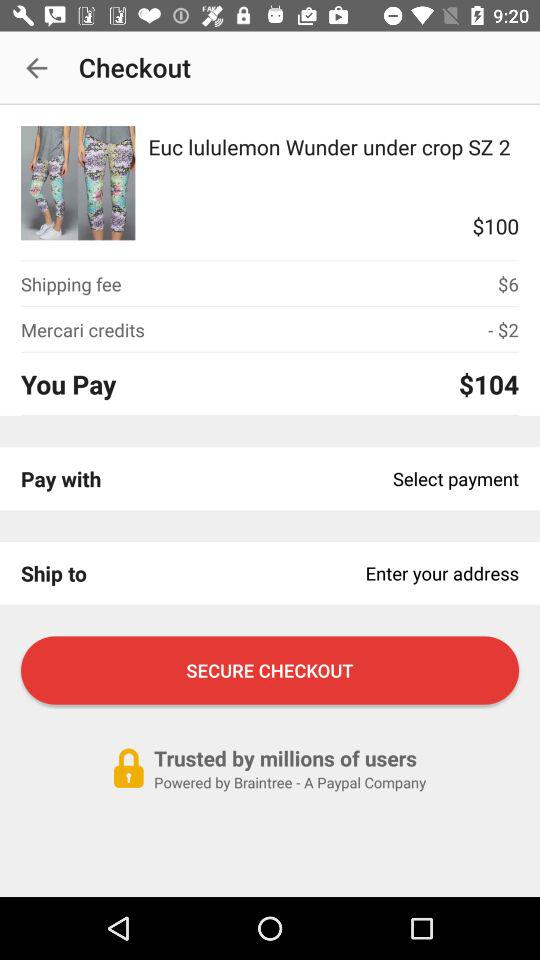With which payment is the user paying?
When the provided information is insufficient, respond with <no answer>. <no answer> 